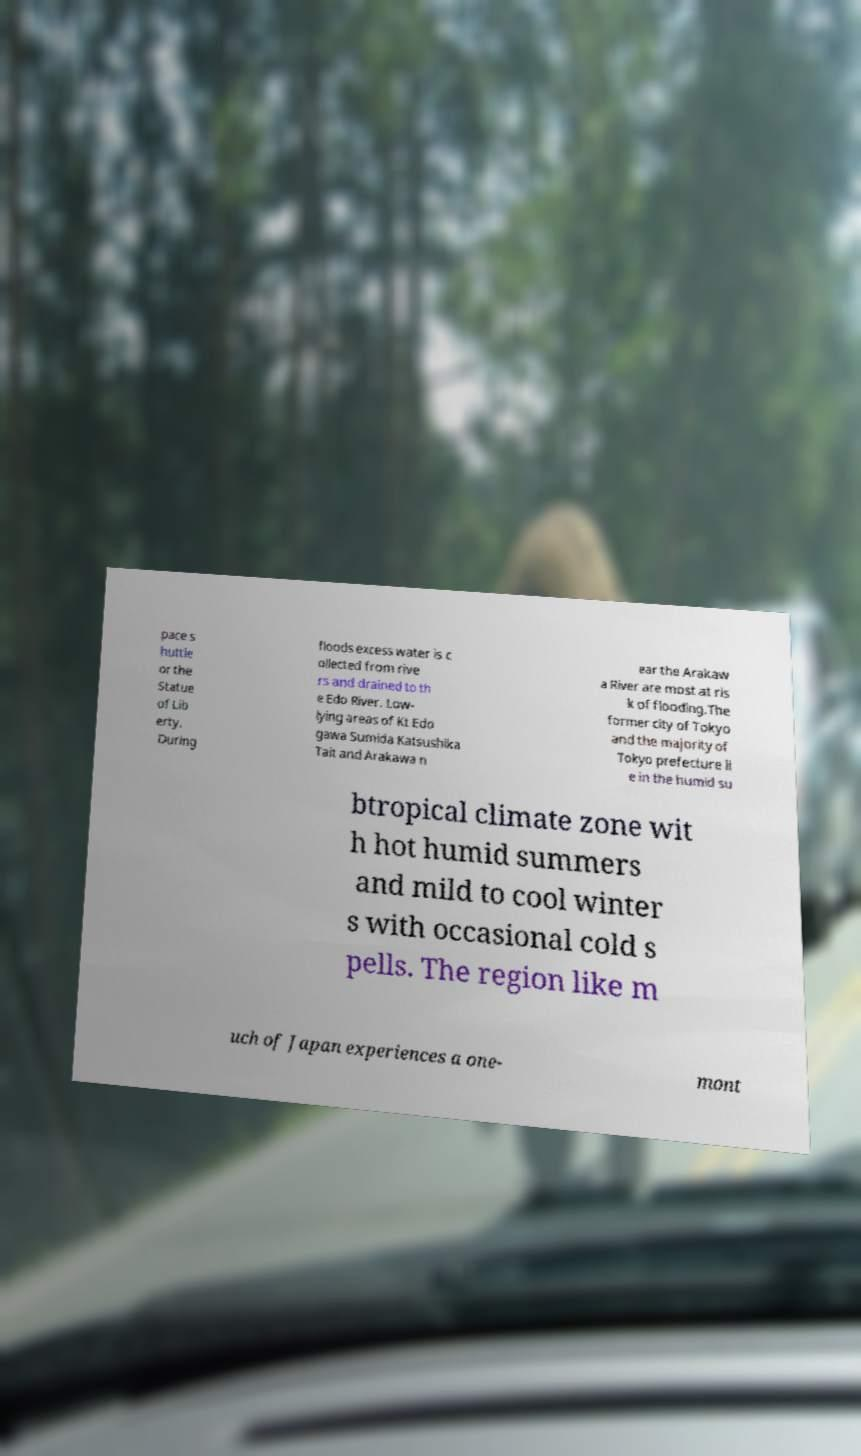Could you assist in decoding the text presented in this image and type it out clearly? pace s huttle or the Statue of Lib erty. During floods excess water is c ollected from rive rs and drained to th e Edo River. Low- lying areas of Kt Edo gawa Sumida Katsushika Tait and Arakawa n ear the Arakaw a River are most at ris k of flooding.The former city of Tokyo and the majority of Tokyo prefecture li e in the humid su btropical climate zone wit h hot humid summers and mild to cool winter s with occasional cold s pells. The region like m uch of Japan experiences a one- mont 